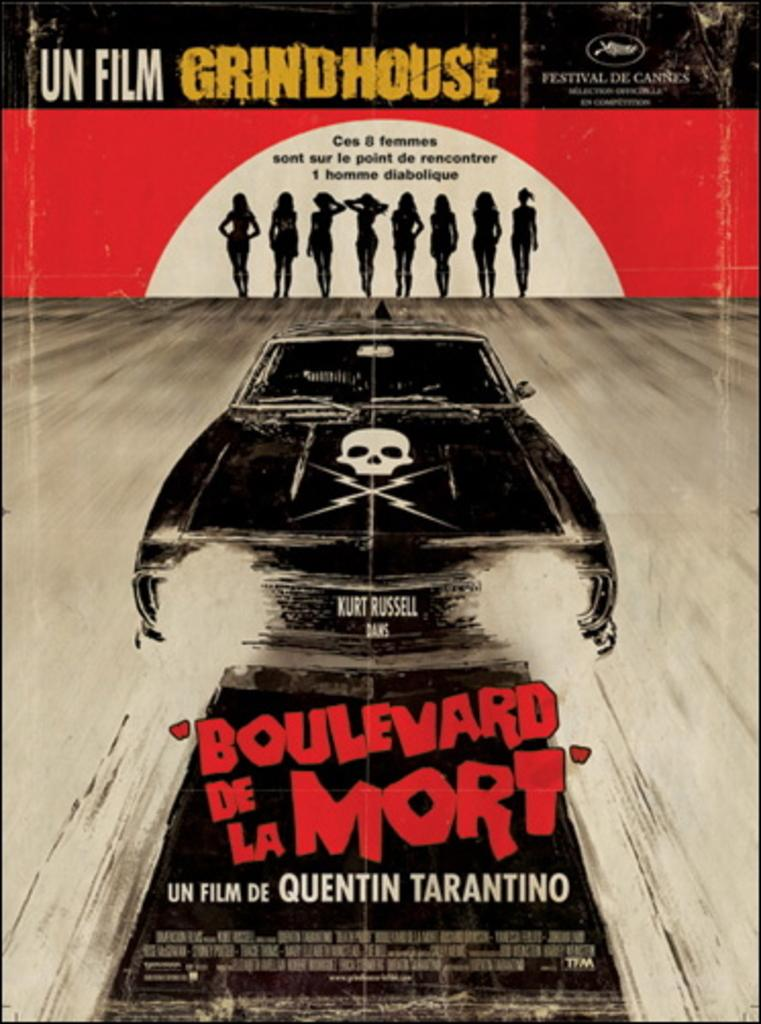<image>
Render a clear and concise summary of the photo. Poster for an ad that says "Un Film Grindhouse" near the top. 